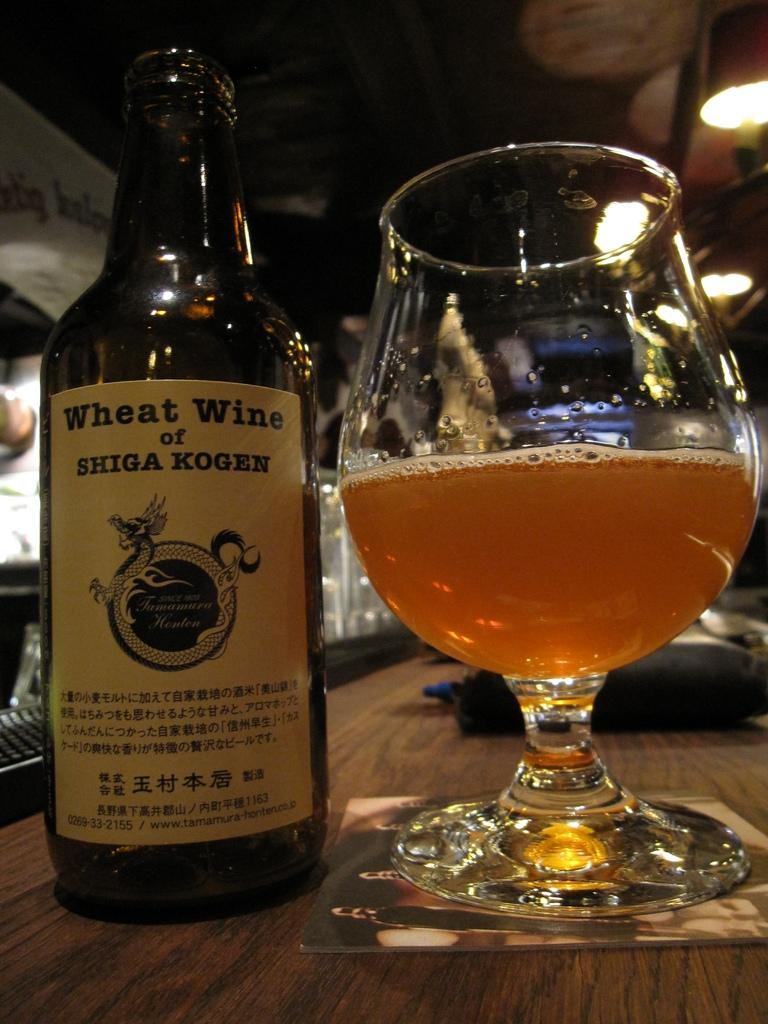<image>
Summarize the visual content of the image. A bottle of wheat wine from Shiga Kogen sits on a bar next to a glass. 